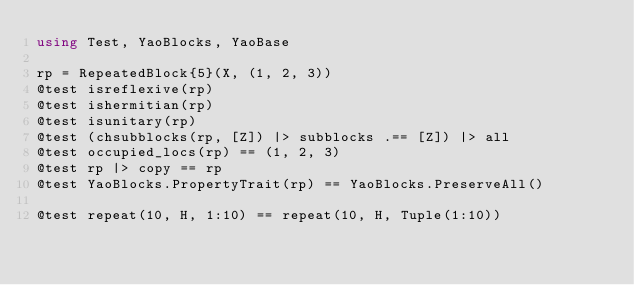Convert code to text. <code><loc_0><loc_0><loc_500><loc_500><_Julia_>using Test, YaoBlocks, YaoBase

rp = RepeatedBlock{5}(X, (1, 2, 3))
@test isreflexive(rp)
@test ishermitian(rp)
@test isunitary(rp)
@test (chsubblocks(rp, [Z]) |> subblocks .== [Z]) |> all
@test occupied_locs(rp) == (1, 2, 3)
@test rp |> copy == rp
@test YaoBlocks.PropertyTrait(rp) == YaoBlocks.PreserveAll()

@test repeat(10, H, 1:10) == repeat(10, H, Tuple(1:10))
</code> 